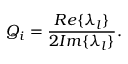Convert formula to latex. <formula><loc_0><loc_0><loc_500><loc_500>Q _ { i } = \frac { R e \{ { \lambda _ { l } } \} } { 2 I m \{ { \lambda _ { l } } \} } .</formula> 